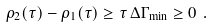Convert formula to latex. <formula><loc_0><loc_0><loc_500><loc_500>\rho _ { 2 } ( \tau ) - \rho _ { 1 } ( \tau ) \geq \tau \, \Delta \Gamma _ { \min } \geq 0 \ .</formula> 